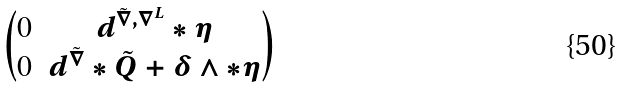Convert formula to latex. <formula><loc_0><loc_0><loc_500><loc_500>\begin{pmatrix} 0 & d ^ { \tilde { \nabla } , \nabla ^ { L } } * \eta \\ 0 & d ^ { \tilde { \nabla } } * \tilde { Q } + \delta \wedge * \eta \end{pmatrix}</formula> 